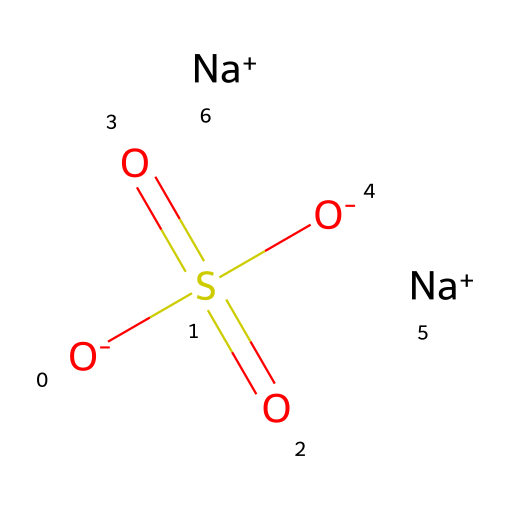how many oxygen atoms are present in the compound? The SMILES representation indicates a sulfur atom bonded to four oxygen atoms: two are doubly bonded (as indicated by the "O=") and two are singly bonded (indicated by the "[O-]"). Therefore, the total count shows there are four oxygen atoms.
Answer: four what is the central atom in this compound? In the given SMILES structure, sulfur is the central atom, as it is indicated by "S" and is bonded to multiple oxygen atoms and sodium ions.
Answer: sulfur how many sodium ions are in the compound? The SMILES representation shows two sodium ions represented by "[Na+]", indicating the presence of two sodium ions.
Answer: two is this compound ionic or covalent? The presence of charged species like sodium ions and negatively charged oxygen atoms suggests this compound has ionic character, as it includes ionic bonds between Na+ and [O-].
Answer: ionic what type of bond connects sulfur to oxygen in this compound? The structure indicates that sulfur is bonded to oxygen through both single and double bonds. The double bonds (denoted by "S=O") indicate a stronger type of bond, while the single bonds (denoted by "S-O") are less strong. Therefore, both types of bonds are present.
Answer: both what makes this sulfur compound hypervalent? Hypervalent compounds can have central atoms that form more bonds than they typically can in simple compounds. Here, sulfur forms six bonds in total (four to oxygen and two through ionic interactions with sodium), which is over the typical octet.
Answer: six bonds 